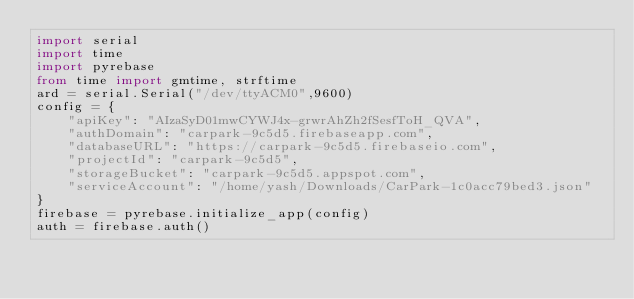<code> <loc_0><loc_0><loc_500><loc_500><_Python_>import serial
import time
import pyrebase
from time import gmtime, strftime    
ard = serial.Serial("/dev/ttyACM0",9600)
config = {
    "apiKey": "AIzaSyD01mwCYWJ4x-grwrAhZh2fSesfToH_QVA",
    "authDomain": "carpark-9c5d5.firebaseapp.com",
    "databaseURL": "https://carpark-9c5d5.firebaseio.com",
    "projectId": "carpark-9c5d5",
    "storageBucket": "carpark-9c5d5.appspot.com",
    "serviceAccount": "/home/yash/Downloads/CarPark-1c0acc79bed3.json"
}
firebase = pyrebase.initialize_app(config)
auth = firebase.auth()</code> 